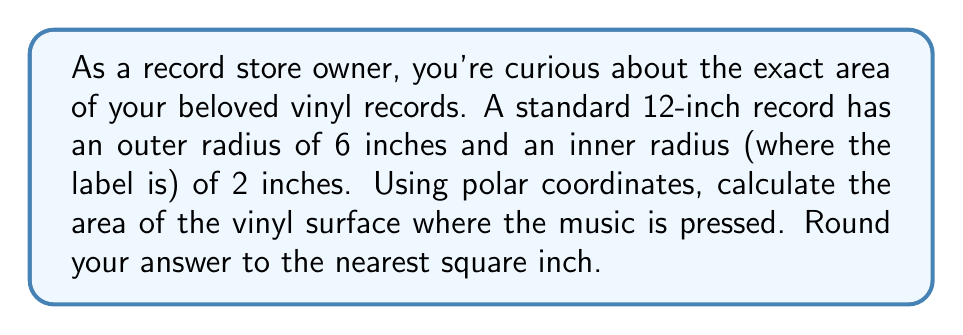Give your solution to this math problem. Let's approach this step-by-step using polar coordinates:

1) The area of a region in polar coordinates is given by the formula:

   $$A = \int_{\theta_1}^{\theta_2} \int_{r_1}^{r_2} r \, dr \, d\theta$$

2) In this case, we're dealing with a full circle, so $\theta$ goes from 0 to $2\pi$.

3) The inner radius $r_1$ is 2 inches, and the outer radius $r_2$ is 6 inches.

4) Substituting these values:

   $$A = \int_{0}^{2\pi} \int_{2}^{6} r \, dr \, d\theta$$

5) We can evaluate the inner integral first:

   $$A = \int_{0}^{2\pi} \left[\frac{r^2}{2}\right]_{2}^{6} \, d\theta$$

6) Evaluating the brackets:

   $$A = \int_{0}^{2\pi} \left(\frac{6^2}{2} - \frac{2^2}{2}\right) \, d\theta$$
   
   $$A = \int_{0}^{2\pi} (18 - 2) \, d\theta = \int_{0}^{2\pi} 16 \, d\theta$$

7) Now we can evaluate the outer integral:

   $$A = 16 \cdot [{\theta}]_{0}^{2\pi} = 16 \cdot 2\pi = 32\pi$$

8) $32\pi \approx 100.53$ square inches

9) Rounding to the nearest square inch gives us 101 square inches.
Answer: 101 square inches 